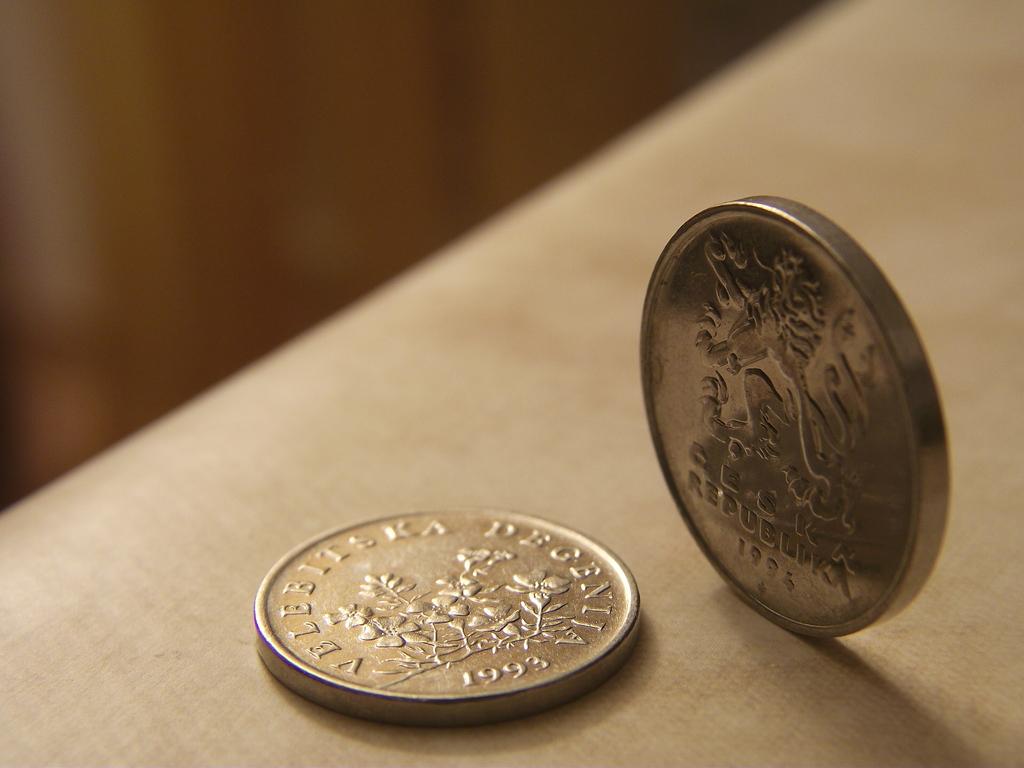In what year is the coin lying flat minted?
Provide a succinct answer. 1993. In what year is the coin standing upright minted?
Ensure brevity in your answer.  1994. 